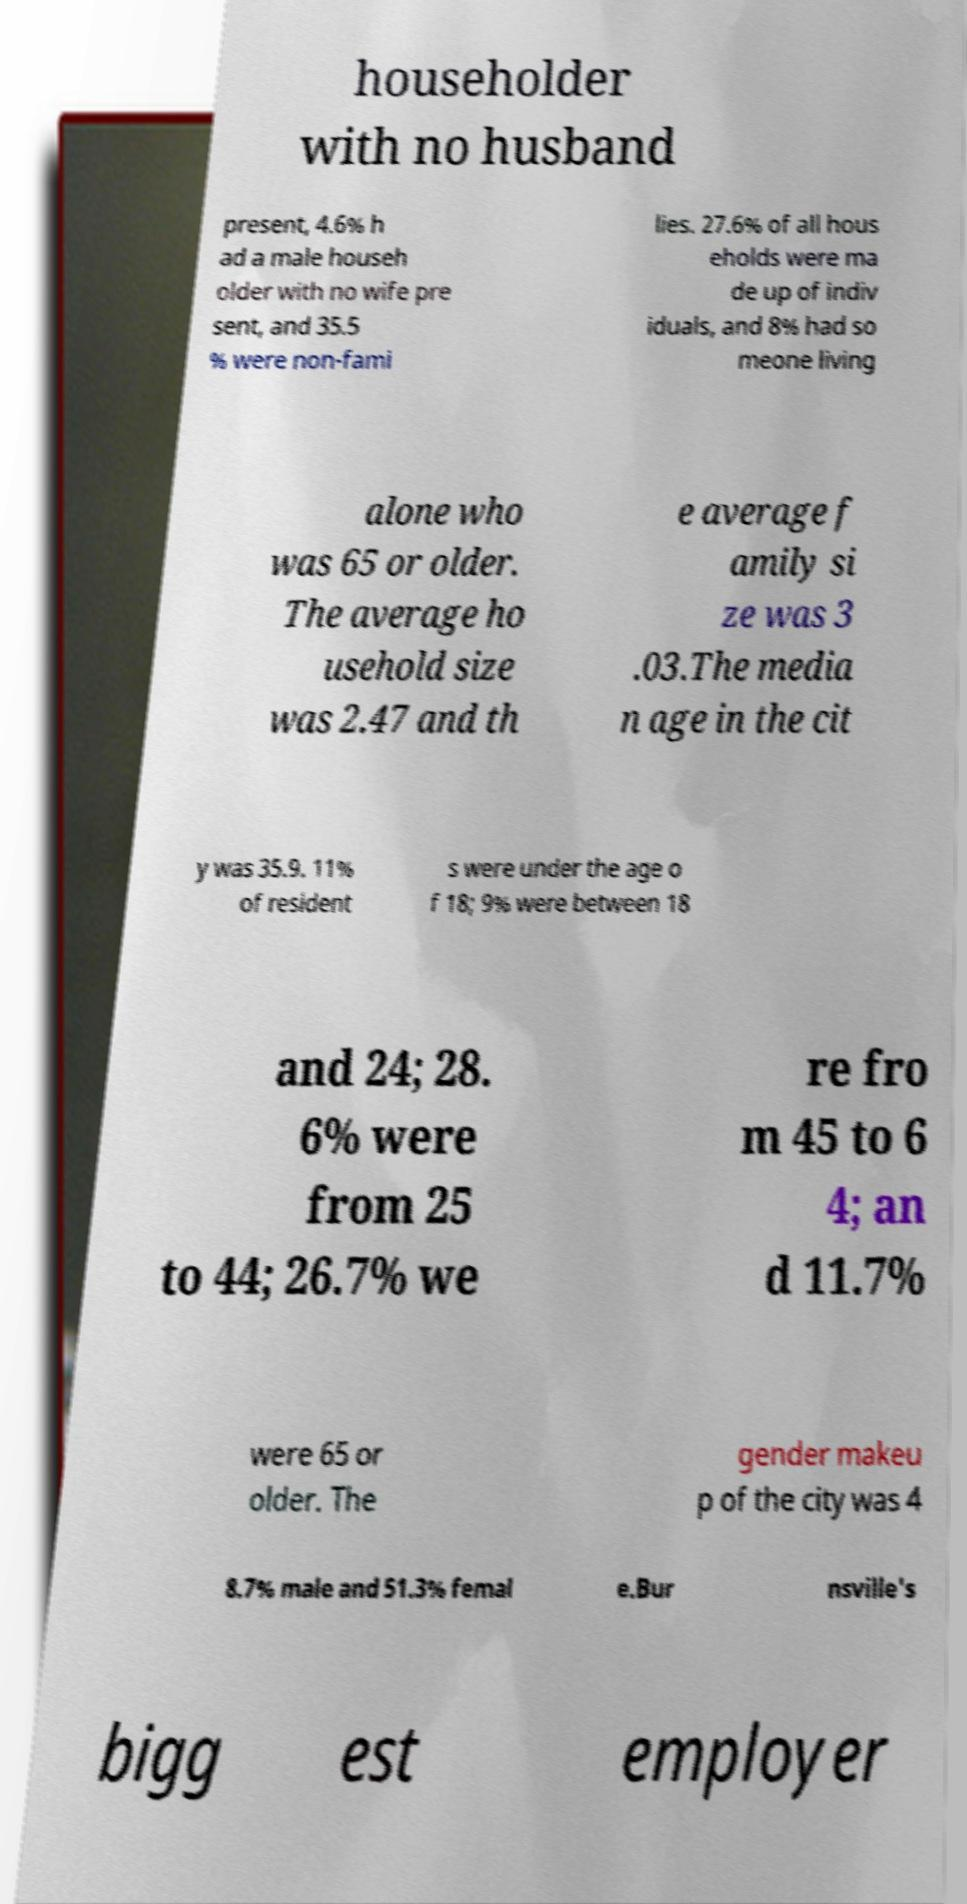I need the written content from this picture converted into text. Can you do that? householder with no husband present, 4.6% h ad a male househ older with no wife pre sent, and 35.5 % were non-fami lies. 27.6% of all hous eholds were ma de up of indiv iduals, and 8% had so meone living alone who was 65 or older. The average ho usehold size was 2.47 and th e average f amily si ze was 3 .03.The media n age in the cit y was 35.9. 11% of resident s were under the age o f 18; 9% were between 18 and 24; 28. 6% were from 25 to 44; 26.7% we re fro m 45 to 6 4; an d 11.7% were 65 or older. The gender makeu p of the city was 4 8.7% male and 51.3% femal e.Bur nsville's bigg est employer 